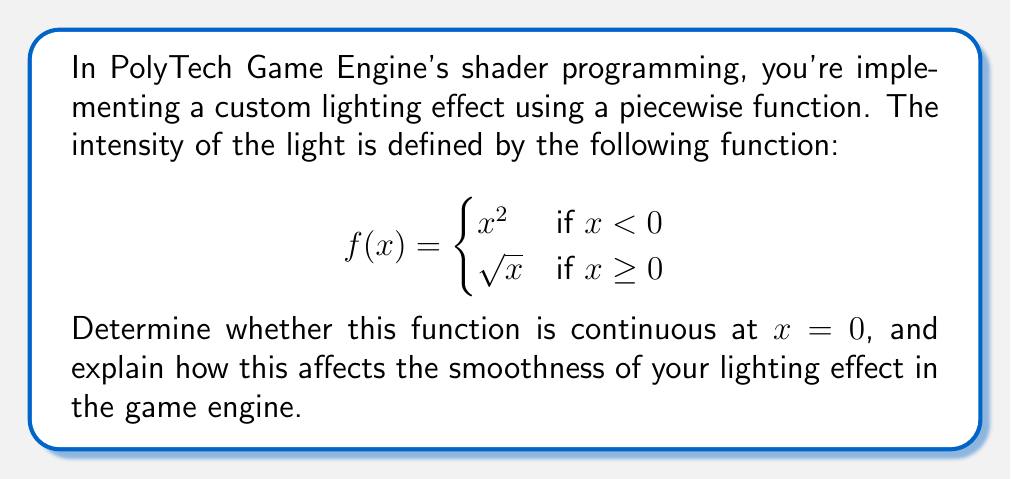Give your solution to this math problem. To determine if the function is continuous at $x = 0$, we need to check three conditions:

1. $f(x)$ is defined at $x = 0$
2. $\lim_{x \to 0^-} f(x)$ exists
3. $\lim_{x \to 0^+} f(x)$ exists
4. $\lim_{x \to 0^-} f(x) = \lim_{x \to 0^+} f(x) = f(0)$

Let's check each condition:

1. $f(0)$ is defined: $f(0) = \sqrt{0} = 0$ (using the second piece of the function)

2. $\lim_{x \to 0^-} f(x) = \lim_{x \to 0^-} x^2 = 0$

3. $\lim_{x \to 0^+} f(x) = \lim_{x \to 0^+} \sqrt{x} = 0$

4. $\lim_{x \to 0^-} f(x) = \lim_{x \to 0^+} f(x) = f(0) = 0$

Since all four conditions are satisfied, the function is continuous at $x = 0$.

In the context of shader programming in PolyTech Game Engine, this continuity ensures that the lighting effect will be smooth and won't have any sudden jumps or artifacts at the transition point (x = 0). This is crucial for creating realistic and visually appealing lighting in games, as discontinuities can lead to noticeable seams or abrupt changes in the rendered image.
Answer: The function $f(x)$ is continuous at $x = 0$, which ensures a smooth lighting effect in the PolyTech Game Engine shader implementation. 